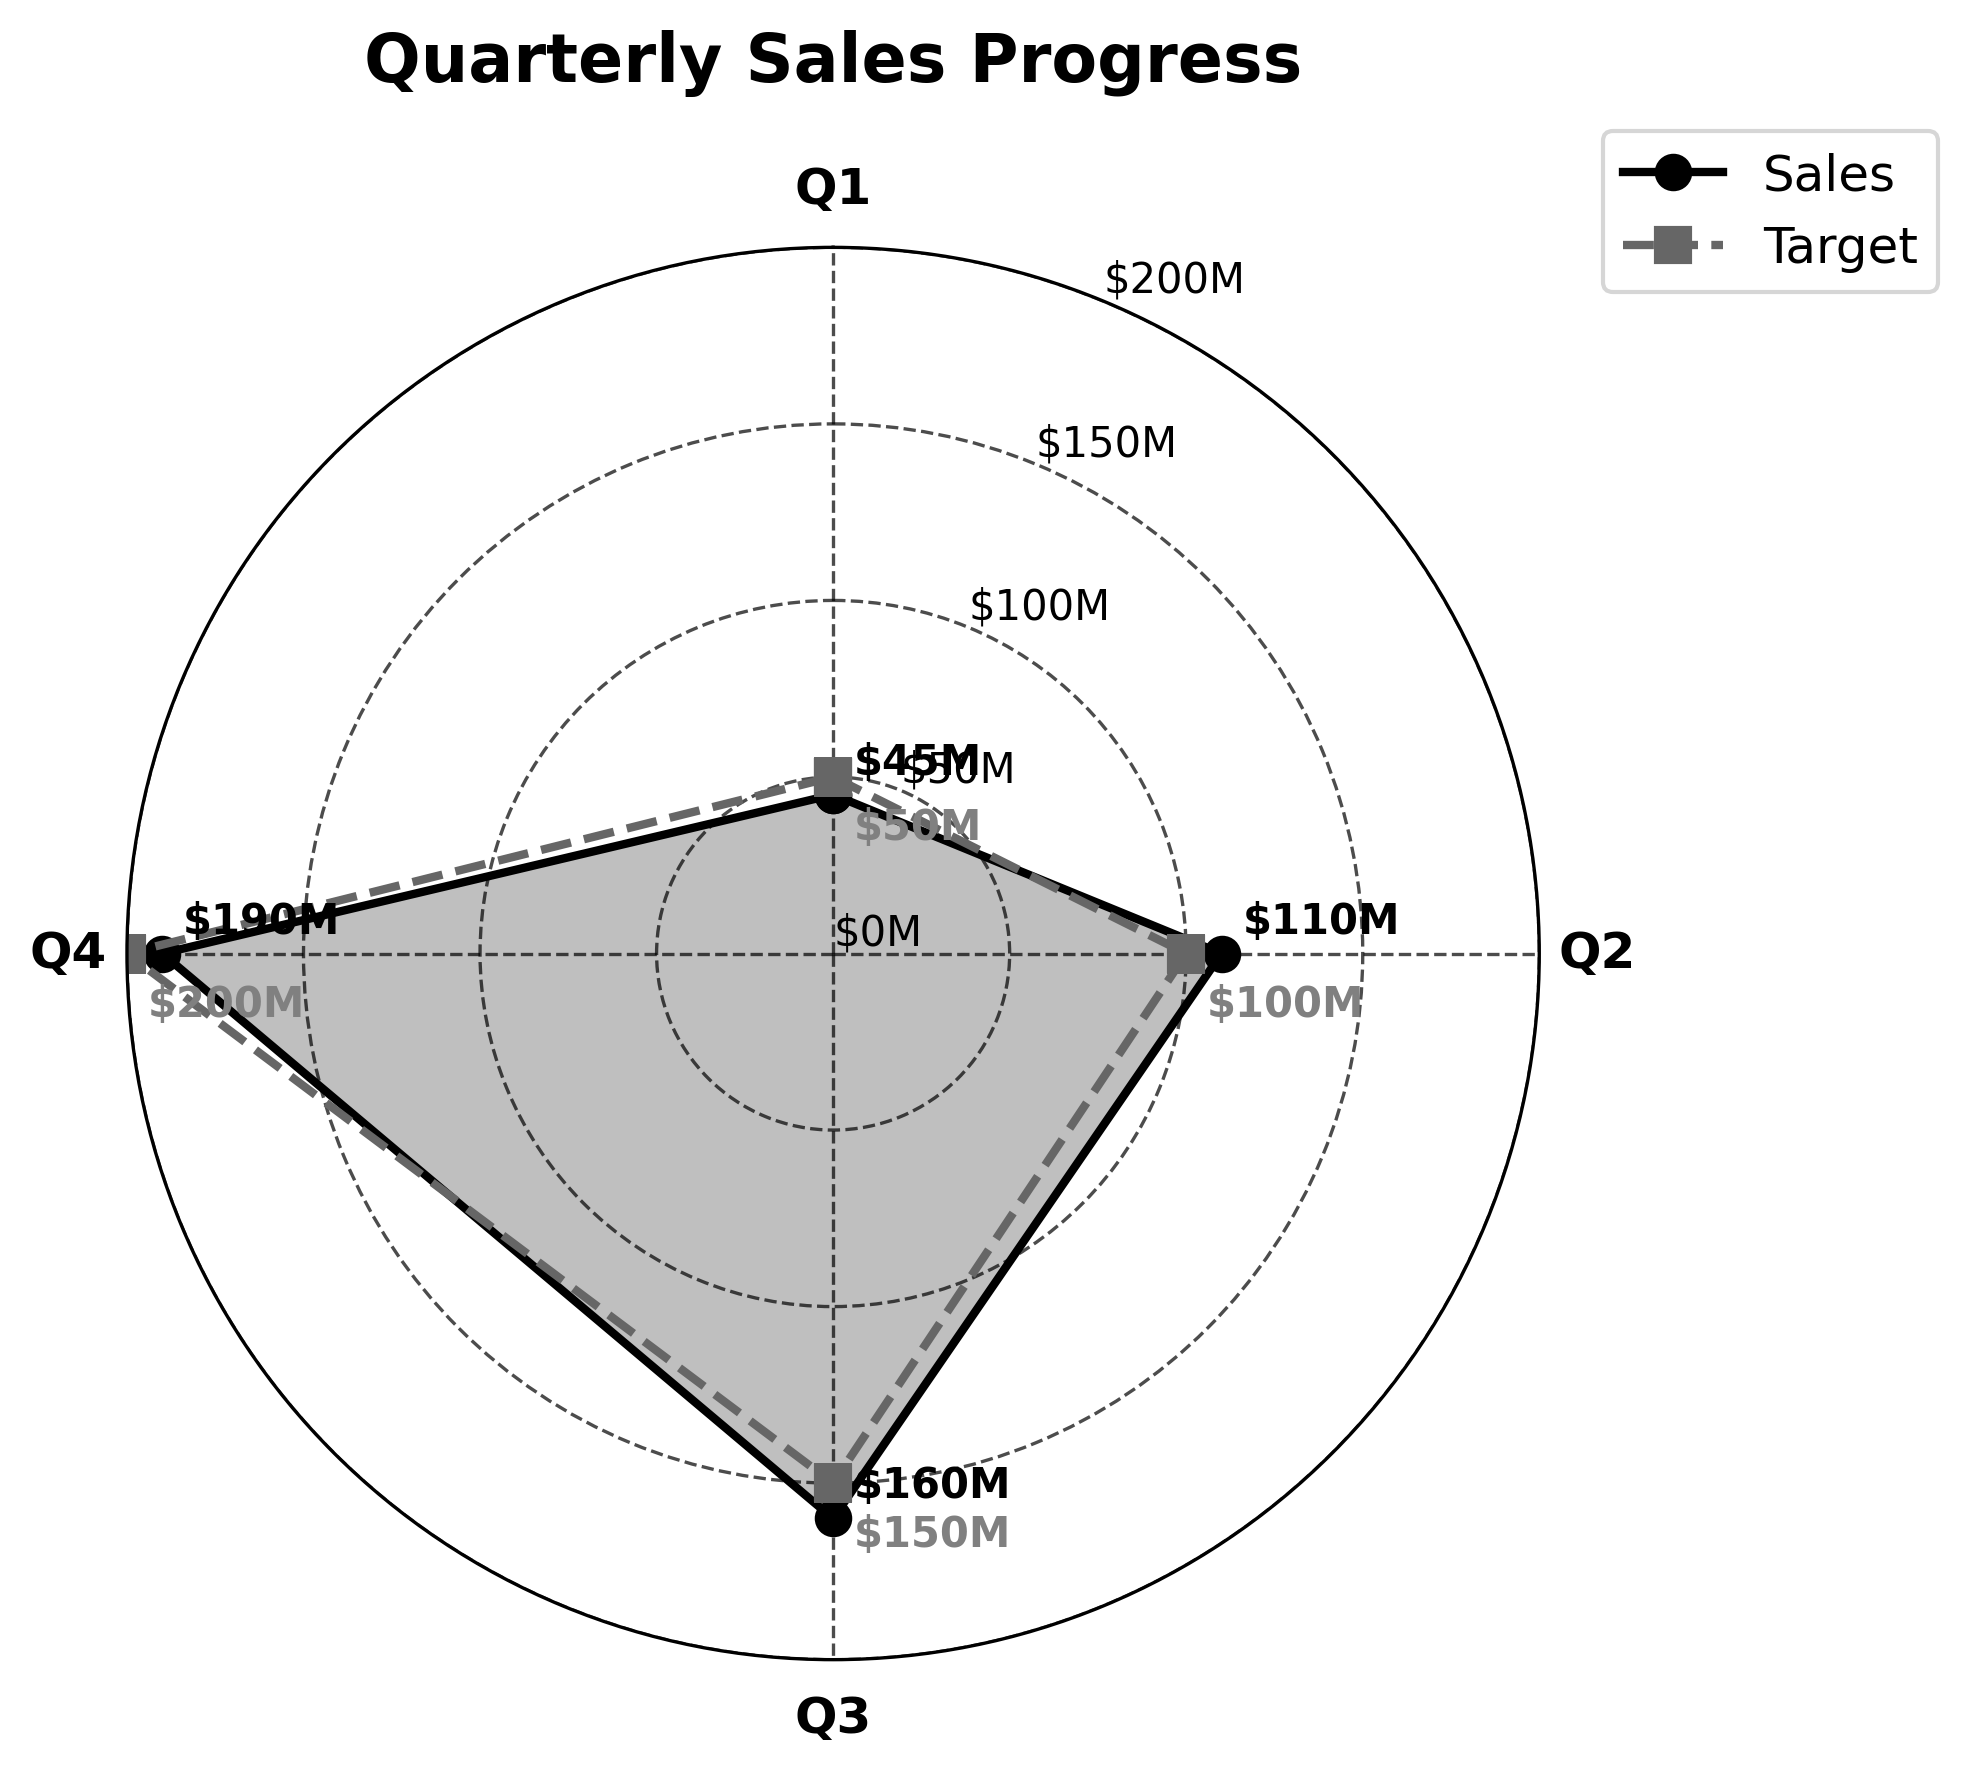what is the title of the plot? The title is prominently located at the top of the plot, giving a clear description of what the figure represents.
Answer: Quarterly Sales Progress What were the sales in Q2? The sales values are plotted on the radial lines and labeled near the data points. The Q2 value is marked and labeled near the respective point in the second quadrant.
Answer: $110M How does Q3's sales compare with its target? Compare the position of the Q3 sales point with the corresponding target point in the same quadrant. The sales point is closer to the center, indicating it falls below the target. The label values also confirm this.
Answer: $160M vs $150M What is the total annual target for the sales? The total annual target is shown in the last row of the data and is reflected in the plot's y-axis limit. It is the same value as the highest tick on the y-axis.
Answer: $200M Which quarter had the highest sales? By comparing all quarterly points, identify the sales point furthest from the center, corresponding to Q4.
Answer: Q4 By how much did sales exceed the target in Q2? Subtract Q2's target from its sales value. The sale value is $110M, and the target is $100M.
Answer: $10M Did all quarters meet their targets? Compare each quarter's sales point with its corresponding target point. If a sales point is equal or beyond its target, it met the target. From the plot, Q1 did not meet its target, but Q2 and Q3 did, while Q4 also fell short.
Answer: No By how much did Q1 fall short of its target? Subtract Q1's sales value from its target. The sales value is $45M, and the target is $50M.
Answer: $5M 